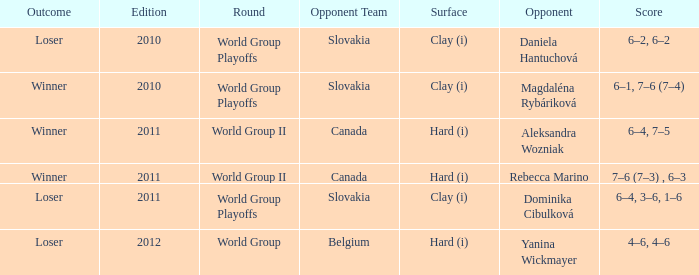Could you parse the entire table? {'header': ['Outcome', 'Edition', 'Round', 'Opponent Team', 'Surface', 'Opponent', 'Score'], 'rows': [['Loser', '2010', 'World Group Playoffs', 'Slovakia', 'Clay (i)', 'Daniela Hantuchová', '6–2, 6–2'], ['Winner', '2010', 'World Group Playoffs', 'Slovakia', 'Clay (i)', 'Magdaléna Rybáriková', '6–1, 7–6 (7–4)'], ['Winner', '2011', 'World Group II', 'Canada', 'Hard (i)', 'Aleksandra Wozniak', '6–4, 7–5'], ['Winner', '2011', 'World Group II', 'Canada', 'Hard (i)', 'Rebecca Marino', '7–6 (7–3) , 6–3'], ['Loser', '2011', 'World Group Playoffs', 'Slovakia', 'Clay (i)', 'Dominika Cibulková', '6–4, 3–6, 1–6'], ['Loser', '2012', 'World Group', 'Belgium', 'Hard (i)', 'Yanina Wickmayer', '4–6, 4–6']]} Which edition of the game involved playing on a clay surface, resulting in a winner? 2010.0. 